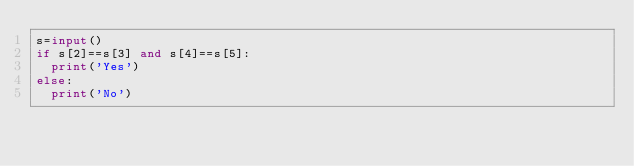<code> <loc_0><loc_0><loc_500><loc_500><_Python_>s=input()
if s[2]==s[3] and s[4]==s[5]:
	print('Yes')
else:
	print('No')</code> 